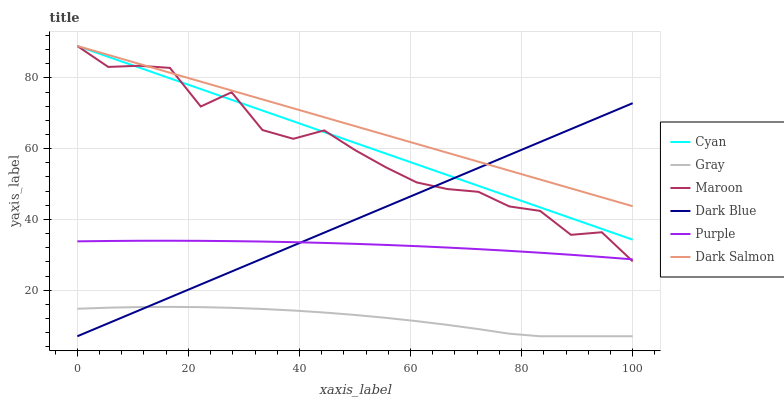Does Purple have the minimum area under the curve?
Answer yes or no. No. Does Purple have the maximum area under the curve?
Answer yes or no. No. Is Purple the smoothest?
Answer yes or no. No. Is Purple the roughest?
Answer yes or no. No. Does Purple have the lowest value?
Answer yes or no. No. Does Purple have the highest value?
Answer yes or no. No. Is Purple less than Cyan?
Answer yes or no. Yes. Is Purple greater than Gray?
Answer yes or no. Yes. Does Purple intersect Cyan?
Answer yes or no. No. 